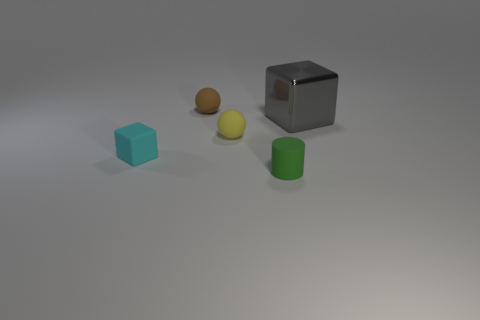Is there anything else that is made of the same material as the big thing?
Offer a very short reply. No. How many things are either tiny green rubber cylinders or big cubes?
Provide a succinct answer. 2. What is the material of the block left of the small rubber object that is in front of the small cyan thing?
Provide a short and direct response. Rubber. Are there any large shiny cylinders of the same color as the matte cube?
Your answer should be compact. No. There is a cylinder that is the same size as the cyan thing; what color is it?
Ensure brevity in your answer.  Green. What is the material of the cube that is to the right of the tiny brown object behind the cube behind the cyan cube?
Ensure brevity in your answer.  Metal. How many objects are either small things on the left side of the small green cylinder or green things that are to the left of the large gray metal object?
Make the answer very short. 4. What is the shape of the thing that is in front of the block on the left side of the rubber cylinder?
Make the answer very short. Cylinder. Are there any tiny cyan objects that have the same material as the small brown sphere?
Make the answer very short. Yes. What is the color of the tiny matte object that is the same shape as the large metal thing?
Provide a succinct answer. Cyan. 